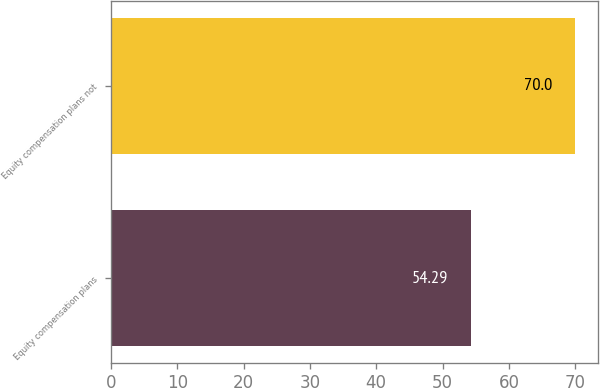Convert chart. <chart><loc_0><loc_0><loc_500><loc_500><bar_chart><fcel>Equity compensation plans<fcel>Equity compensation plans not<nl><fcel>54.29<fcel>70<nl></chart> 